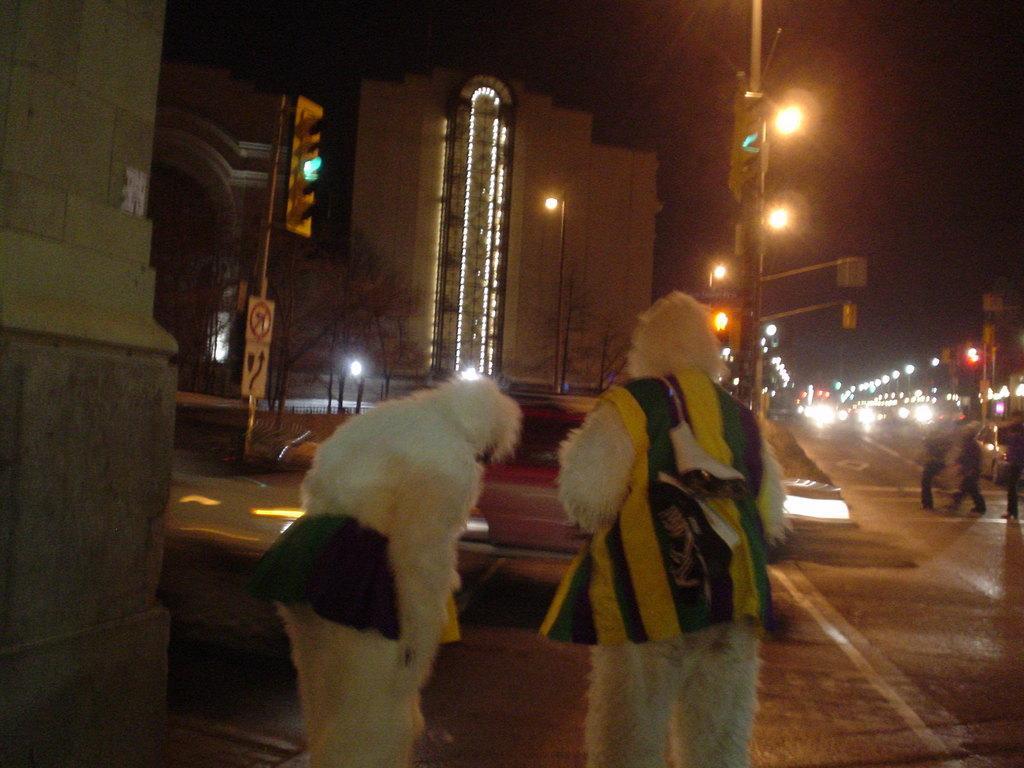Can you describe this image briefly? In this image, we can see two persons wearing fancy dresses. There is a building and some lights in the middle of the image. There is a sign board beside the road. There is a sky at the top of the image. There are two persons on the right side of the image walking on the road. 